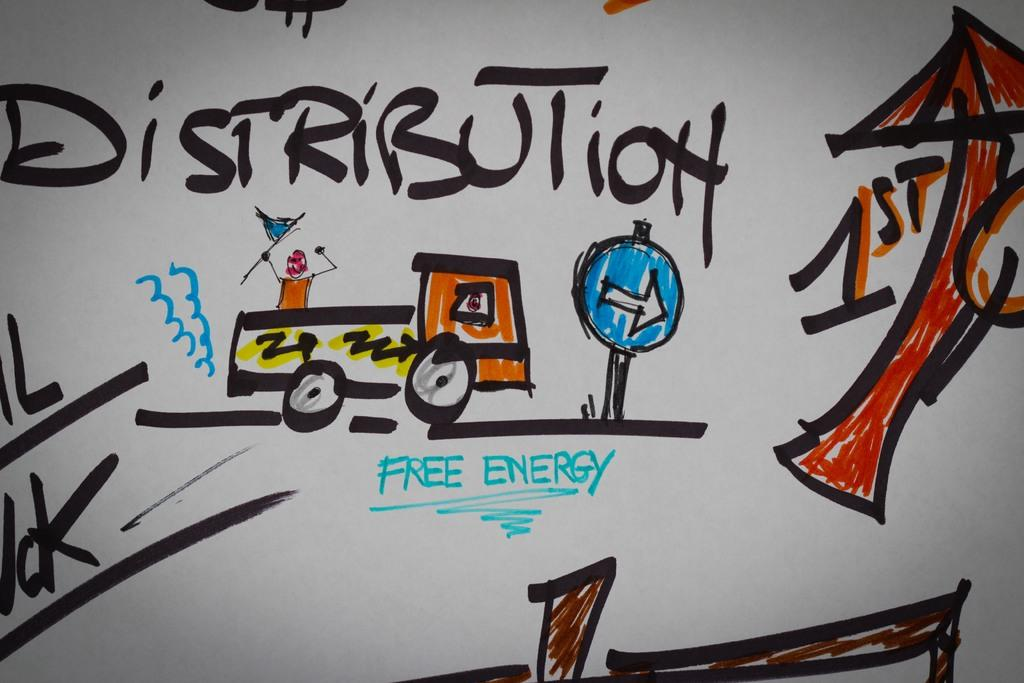What is the main subject of the image? The main subject of the image is a sketch. What can be seen within the sketch? The sketch contains pictures. Are there any words or letters on the sketch? Yes, there is text on the surface of the sketch. Can you hear the plant making a sound in the image? There is no plant present in the image, and therefore no sound can be heard. How does the sketch kick the ball in the image? There is no ball or kicking action in the image; it features a sketch with pictures and text. 